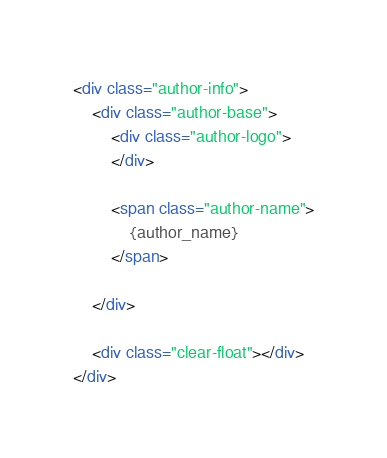<code> <loc_0><loc_0><loc_500><loc_500><_HTML_><div class="author-info">
    <div class="author-base">
        <div class="author-logo">
        </div>

        <span class="author-name">
            {author_name}
        </span>

    </div>

    <div class="clear-float"></div>
</div>
</code> 